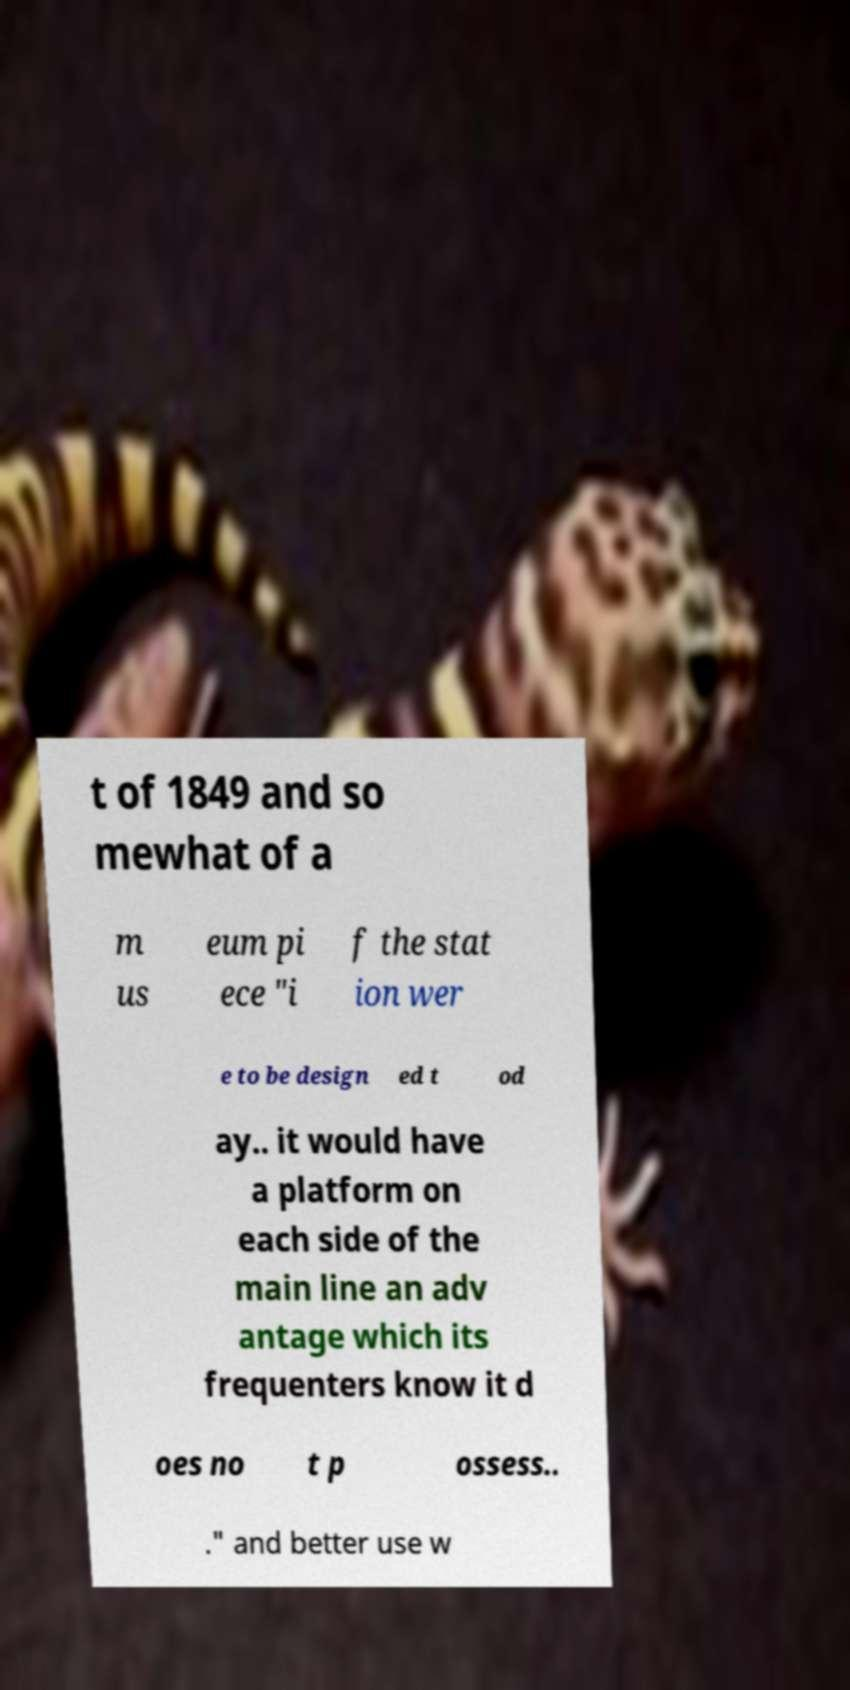I need the written content from this picture converted into text. Can you do that? t of 1849 and so mewhat of a m us eum pi ece "i f the stat ion wer e to be design ed t od ay.. it would have a platform on each side of the main line an adv antage which its frequenters know it d oes no t p ossess.. ." and better use w 